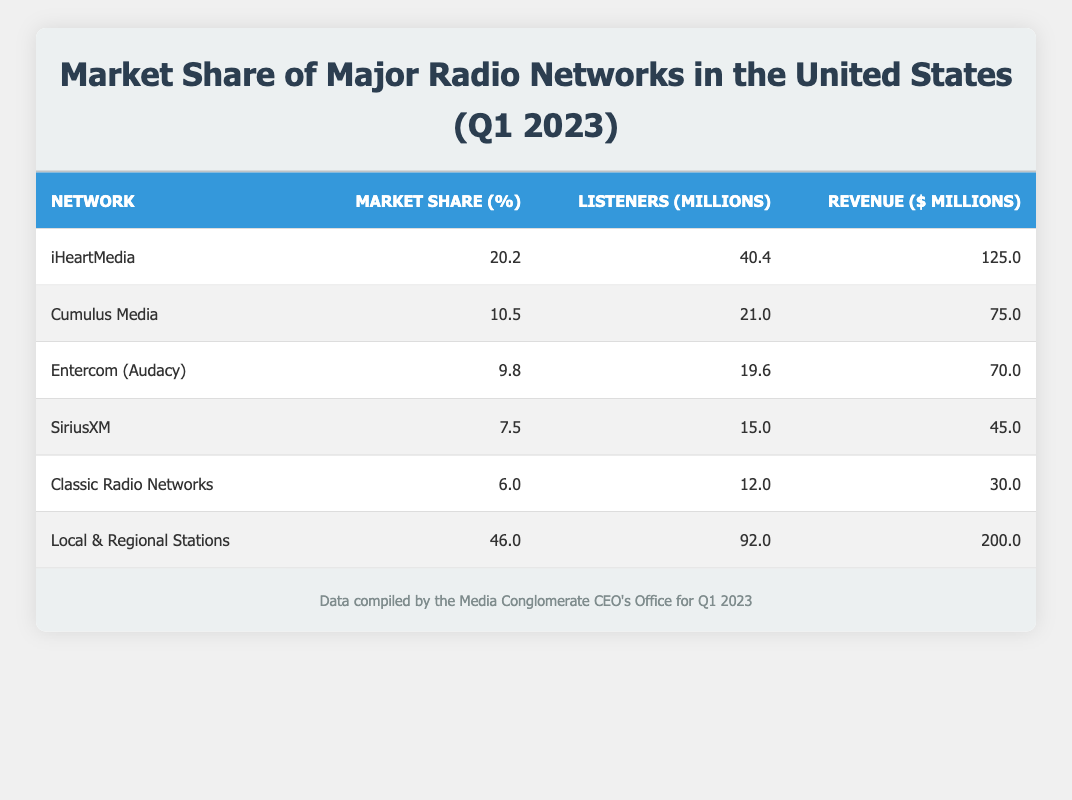What is the market share percentage of iHeartMedia? The table directly shows that iHeartMedia has a market share percentage of 20.2%.
Answer: 20.2 How many listeners does Local & Regional Stations have in millions? Referring to the table, Local & Regional Stations has 92 million listeners listed.
Answer: 92 What is the total market share percentage of Cumulus Media and Entercom (Audacy)? To compute the total market share percentage, add Cumulus Media's 10.5% and Entercom (Audacy)'s 9.8%, which gives 10.5 + 9.8 = 20.3%.
Answer: 20.3 Is it true that SiriusXM has more listeners than Classic Radio Networks? According to the table, SiriusXM has 15 million listeners, while Classic Radio Networks has 12 million listeners. Therefore, it is true.
Answer: Yes What is the total revenue of all networks listed in the table? To find the total revenue, sum the revenue values: 125 + 75 + 70 + 45 + 30 + 200 = 545 million dollars.
Answer: 545 Which network has the least market share percentage? The table indicates that Classic Radio Networks has the least market share percentage at 6.0%.
Answer: Classic Radio Networks What is the average listeners in millions for the radio networks listed in the table? Calculate the average by summing the listeners: 40.4 + 21.0 + 19.6 + 15.0 + 12.0 + 92.0 = 200 million. Then divide by the number of networks, 6. So, 200 / 6 = 33.33 million.
Answer: 33.33 Which network has a higher revenue: Entercom (Audacy) or Classic Radio Networks? According to the table, Entercom (Audacy) has a revenue of 70 million dollars while Classic Radio Networks has 30 million dollars. Thus, Entercom (Audacy) has higher revenue.
Answer: Entercom (Audacy) Are Local & Regional Stations the largest network by listeners and revenue? Both the number of listeners and revenue for Local & Regional Stations are 92 million and 200 million, respectively, which is higher than all other networks listed. Thus, this statement is true.
Answer: Yes 